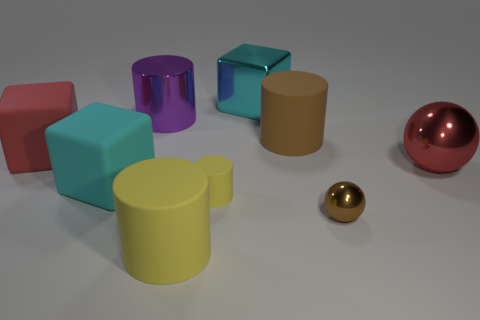Can you describe the colors and shapes of the objects in the image? Certainly! The image features a variety of geometric shapes with different colors. There is a purple cylinder, a blue cube, an orange square prism, a cyan cube, a yellow cylinder, a red cuboid, and two spheres - one golden and one larger red sphere. These shapes together provide a playful mix of basic 3D geometry. 